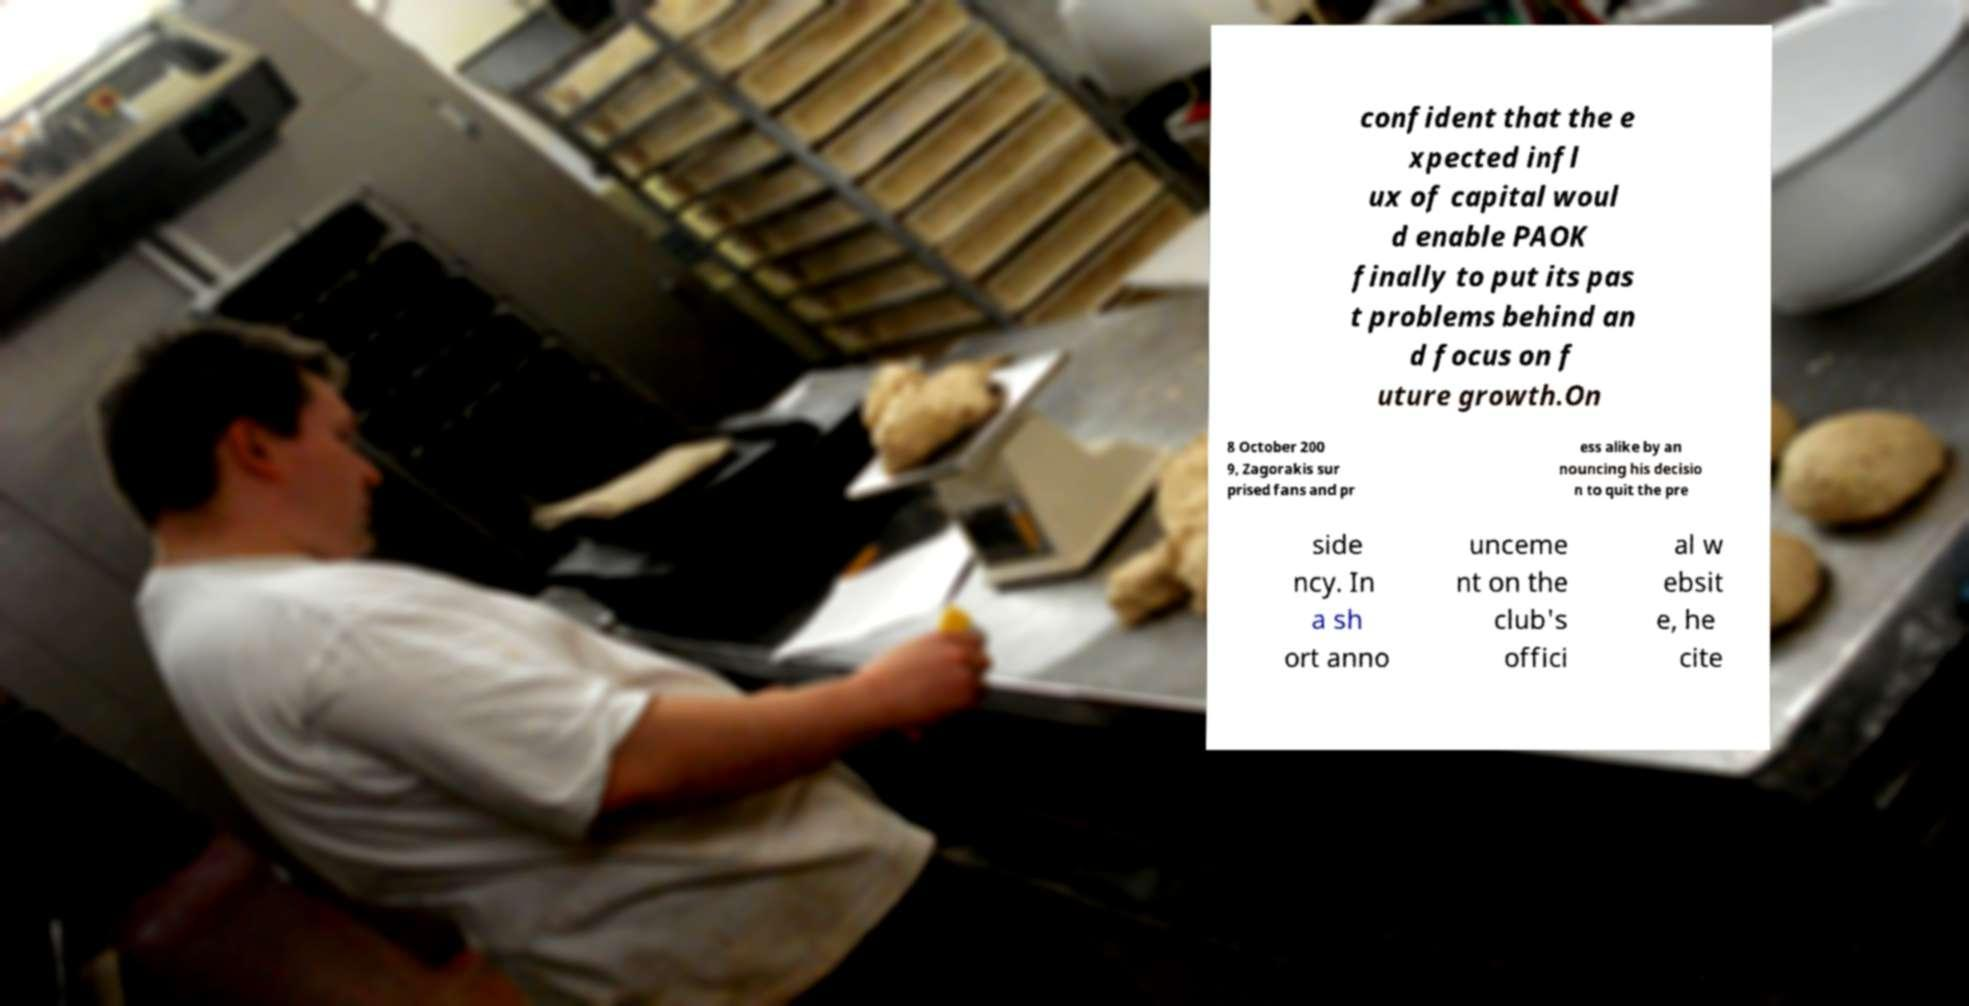Please identify and transcribe the text found in this image. confident that the e xpected infl ux of capital woul d enable PAOK finally to put its pas t problems behind an d focus on f uture growth.On 8 October 200 9, Zagorakis sur prised fans and pr ess alike by an nouncing his decisio n to quit the pre side ncy. In a sh ort anno unceme nt on the club's offici al w ebsit e, he cite 